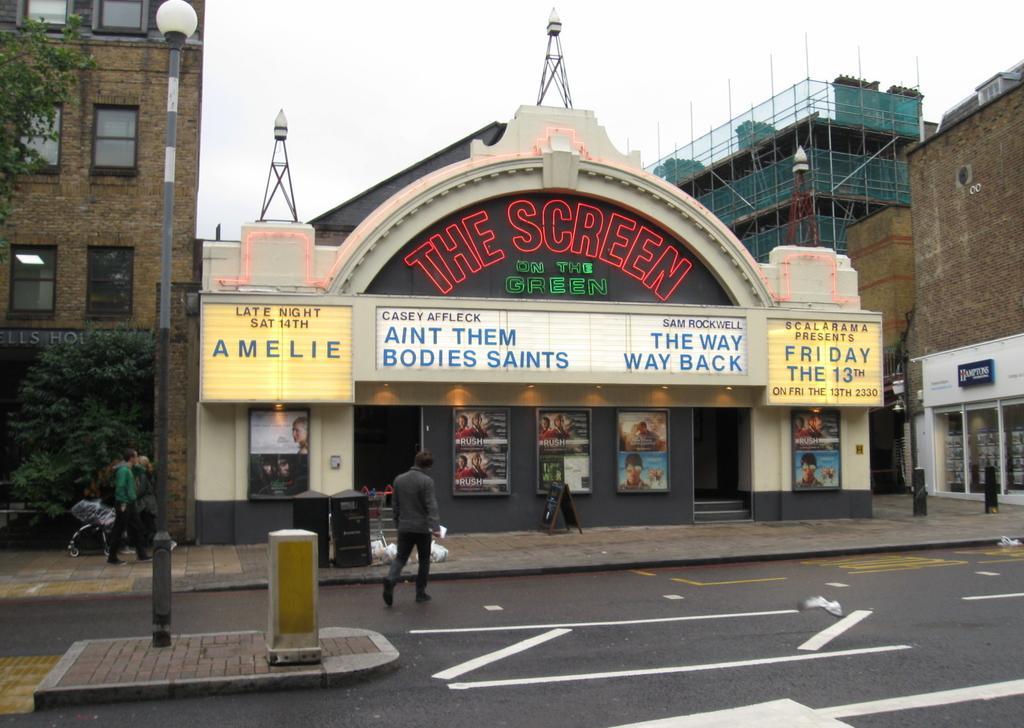Could you give a brief overview of what you see in this image? The picture is clicked outside. In the foreground we can see the group of persons walking on the ground and we can see some objects on the ground and we can see the text on the building and the pictures and text on the banners. On the left we can see a lamp attached to the pole and we can see the buildings, metal rods, trees and some other objects. In the background we can see the sky, net and some other objects. 